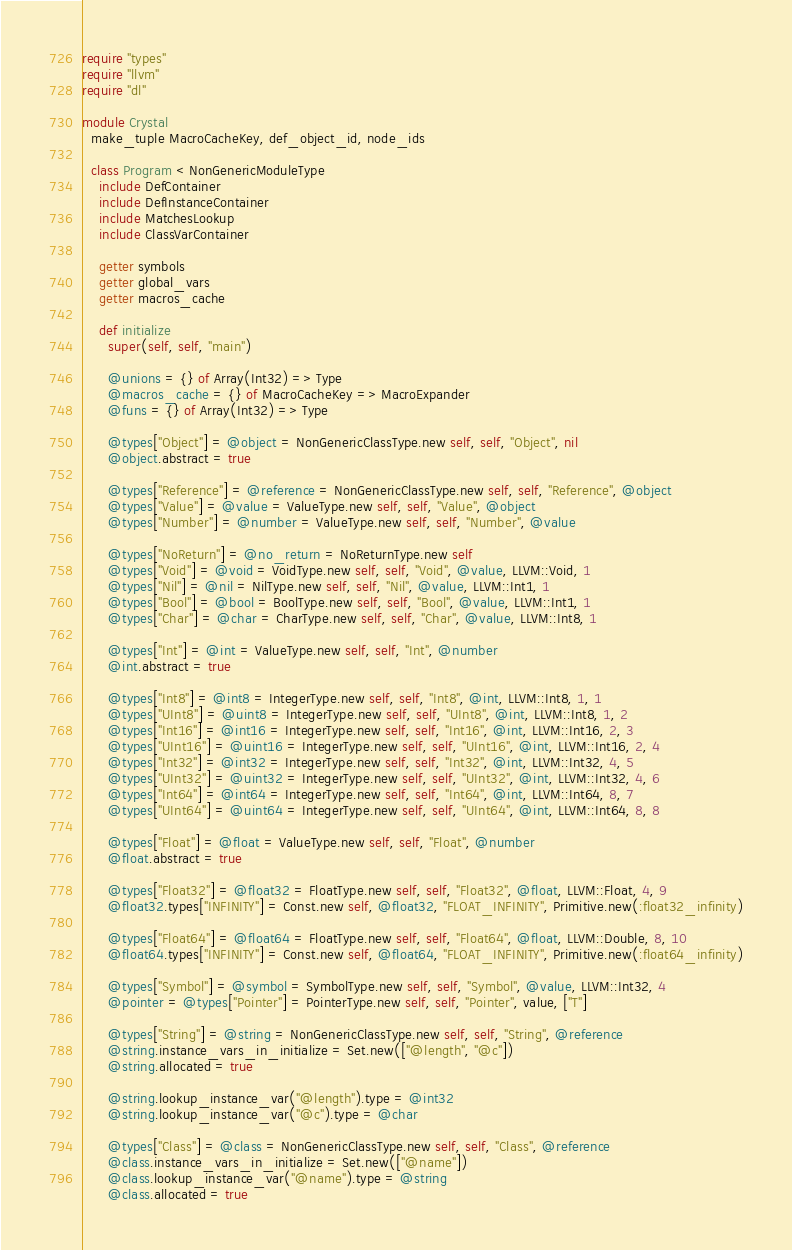<code> <loc_0><loc_0><loc_500><loc_500><_Crystal_>require "types"
require "llvm"
require "dl"

module Crystal
  make_tuple MacroCacheKey, def_object_id, node_ids

  class Program < NonGenericModuleType
    include DefContainer
    include DefInstanceContainer
    include MatchesLookup
    include ClassVarContainer

    getter symbols
    getter global_vars
    getter macros_cache

    def initialize
      super(self, self, "main")

      @unions = {} of Array(Int32) => Type
      @macros_cache = {} of MacroCacheKey => MacroExpander
      @funs = {} of Array(Int32) => Type

      @types["Object"] = @object = NonGenericClassType.new self, self, "Object", nil
      @object.abstract = true

      @types["Reference"] = @reference = NonGenericClassType.new self, self, "Reference", @object
      @types["Value"] = @value = ValueType.new self, self, "Value", @object
      @types["Number"] = @number = ValueType.new self, self, "Number", @value

      @types["NoReturn"] = @no_return = NoReturnType.new self
      @types["Void"] = @void = VoidType.new self, self, "Void", @value, LLVM::Void, 1
      @types["Nil"] = @nil = NilType.new self, self, "Nil", @value, LLVM::Int1, 1
      @types["Bool"] = @bool = BoolType.new self, self, "Bool", @value, LLVM::Int1, 1
      @types["Char"] = @char = CharType.new self, self, "Char", @value, LLVM::Int8, 1

      @types["Int"] = @int = ValueType.new self, self, "Int", @number
      @int.abstract = true

      @types["Int8"] = @int8 = IntegerType.new self, self, "Int8", @int, LLVM::Int8, 1, 1
      @types["UInt8"] = @uint8 = IntegerType.new self, self, "UInt8", @int, LLVM::Int8, 1, 2
      @types["Int16"] = @int16 = IntegerType.new self, self, "Int16", @int, LLVM::Int16, 2, 3
      @types["UInt16"] = @uint16 = IntegerType.new self, self, "UInt16", @int, LLVM::Int16, 2, 4
      @types["Int32"] = @int32 = IntegerType.new self, self, "Int32", @int, LLVM::Int32, 4, 5
      @types["UInt32"] = @uint32 = IntegerType.new self, self, "UInt32", @int, LLVM::Int32, 4, 6
      @types["Int64"] = @int64 = IntegerType.new self, self, "Int64", @int, LLVM::Int64, 8, 7
      @types["UInt64"] = @uint64 = IntegerType.new self, self, "UInt64", @int, LLVM::Int64, 8, 8

      @types["Float"] = @float = ValueType.new self, self, "Float", @number
      @float.abstract = true

      @types["Float32"] = @float32 = FloatType.new self, self, "Float32", @float, LLVM::Float, 4, 9
      @float32.types["INFINITY"] = Const.new self, @float32, "FLOAT_INFINITY", Primitive.new(:float32_infinity)

      @types["Float64"] = @float64 = FloatType.new self, self, "Float64", @float, LLVM::Double, 8, 10
      @float64.types["INFINITY"] = Const.new self, @float64, "FLOAT_INFINITY", Primitive.new(:float64_infinity)

      @types["Symbol"] = @symbol = SymbolType.new self, self, "Symbol", @value, LLVM::Int32, 4
      @pointer = @types["Pointer"] = PointerType.new self, self, "Pointer", value, ["T"]

      @types["String"] = @string = NonGenericClassType.new self, self, "String", @reference
      @string.instance_vars_in_initialize = Set.new(["@length", "@c"])
      @string.allocated = true

      @string.lookup_instance_var("@length").type = @int32
      @string.lookup_instance_var("@c").type = @char

      @types["Class"] = @class = NonGenericClassType.new self, self, "Class", @reference
      @class.instance_vars_in_initialize = Set.new(["@name"])
      @class.lookup_instance_var("@name").type = @string
      @class.allocated = true
</code> 